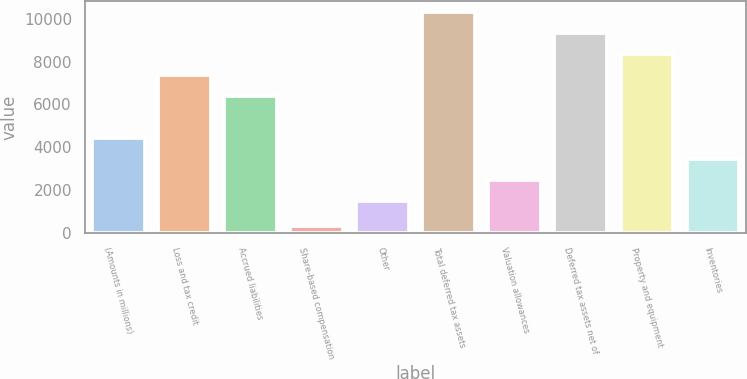<chart> <loc_0><loc_0><loc_500><loc_500><bar_chart><fcel>(Amounts in millions)<fcel>Loss and tax credit<fcel>Accrued liabilities<fcel>Share-based compensation<fcel>Other<fcel>Total deferred tax assets<fcel>Valuation allowances<fcel>Deferred tax assets net of<fcel>Property and equipment<fcel>Inventories<nl><fcel>4419.4<fcel>7364.8<fcel>6383<fcel>309<fcel>1474<fcel>10310.2<fcel>2455.8<fcel>9328.4<fcel>8346.6<fcel>3437.6<nl></chart> 